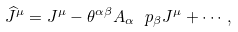Convert formula to latex. <formula><loc_0><loc_0><loc_500><loc_500>\widehat { J } ^ { \mu } = J ^ { \mu } - \theta ^ { \alpha \beta } A _ { \alpha } \ p _ { \beta } J ^ { \mu } + \cdots ,</formula> 